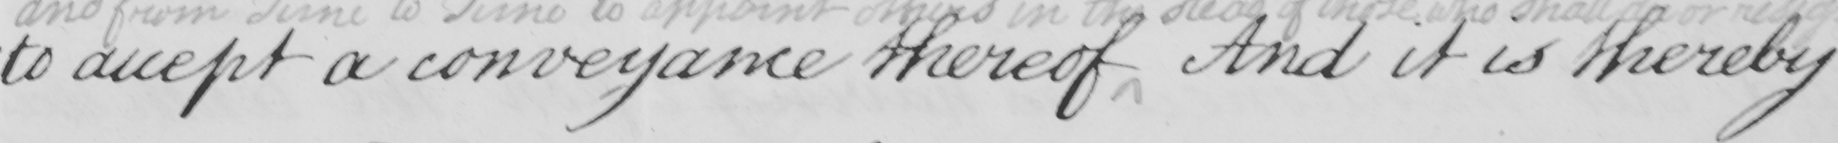What is written in this line of handwriting? to accept a conveyance thereof And it is thereby 